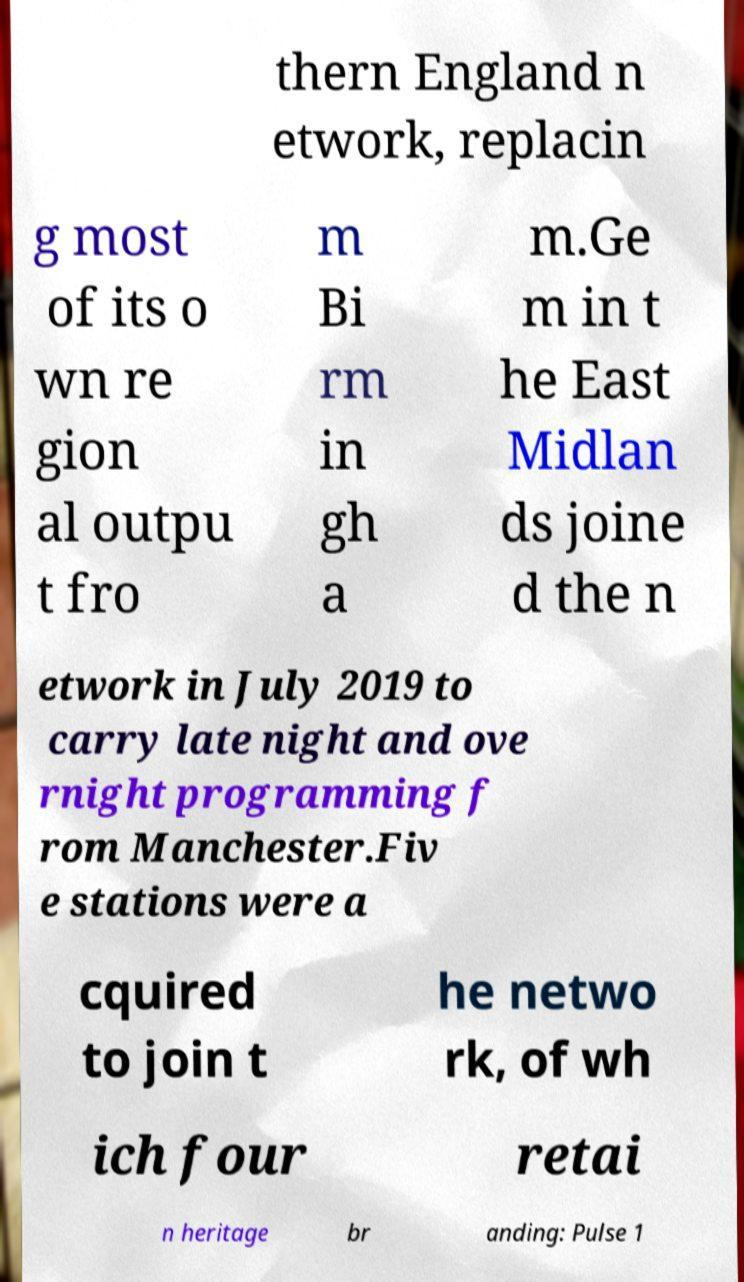There's text embedded in this image that I need extracted. Can you transcribe it verbatim? thern England n etwork, replacin g most of its o wn re gion al outpu t fro m Bi rm in gh a m.Ge m in t he East Midlan ds joine d the n etwork in July 2019 to carry late night and ove rnight programming f rom Manchester.Fiv e stations were a cquired to join t he netwo rk, of wh ich four retai n heritage br anding: Pulse 1 